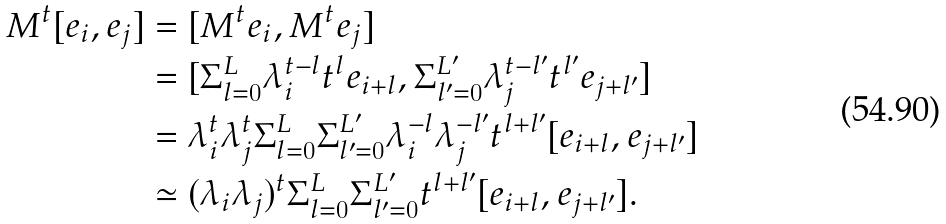<formula> <loc_0><loc_0><loc_500><loc_500>M ^ { t } [ e _ { i } , e _ { j } ] & = [ M ^ { t } e _ { i } , M ^ { t } e _ { j } ] \\ & = [ \Sigma _ { l = 0 } ^ { L } \lambda _ { i } ^ { t - l } t ^ { l } e _ { i + l } , \Sigma _ { l ^ { \prime } = 0 } ^ { L ^ { \prime } } \lambda _ { j } ^ { t - l ^ { \prime } } t ^ { l ^ { \prime } } e _ { j + l ^ { \prime } } ] \\ & = \lambda _ { i } ^ { t } \lambda _ { j } ^ { t } \Sigma _ { l = 0 } ^ { L } \Sigma _ { l ^ { \prime } = 0 } ^ { L ^ { \prime } } \lambda _ { i } ^ { - l } \lambda _ { j } ^ { - l ^ { \prime } } t ^ { l + l ^ { \prime } } [ e _ { i + l } , e _ { j + l ^ { \prime } } ] \\ & \simeq ( \lambda _ { i } \lambda _ { j } ) ^ { t } \Sigma _ { l = 0 } ^ { L } \Sigma _ { l ^ { \prime } = 0 } ^ { L ^ { \prime } } t ^ { l + l ^ { \prime } } [ e _ { i + l } , e _ { j + l ^ { \prime } } ] . \\</formula> 